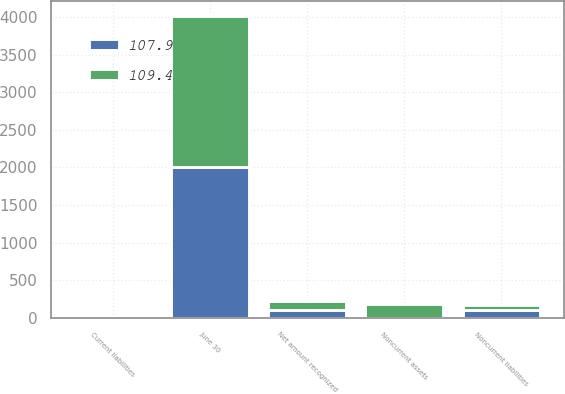Convert chart. <chart><loc_0><loc_0><loc_500><loc_500><stacked_bar_chart><ecel><fcel>June 30<fcel>Noncurrent assets<fcel>Current liabilities<fcel>Noncurrent liabilities<fcel>Net amount recognized<nl><fcel>107.9<fcel>2009<fcel>1<fcel>4.4<fcel>104.5<fcel>107.9<nl><fcel>109.4<fcel>2008<fcel>180.6<fcel>3.6<fcel>67.6<fcel>109.4<nl></chart> 